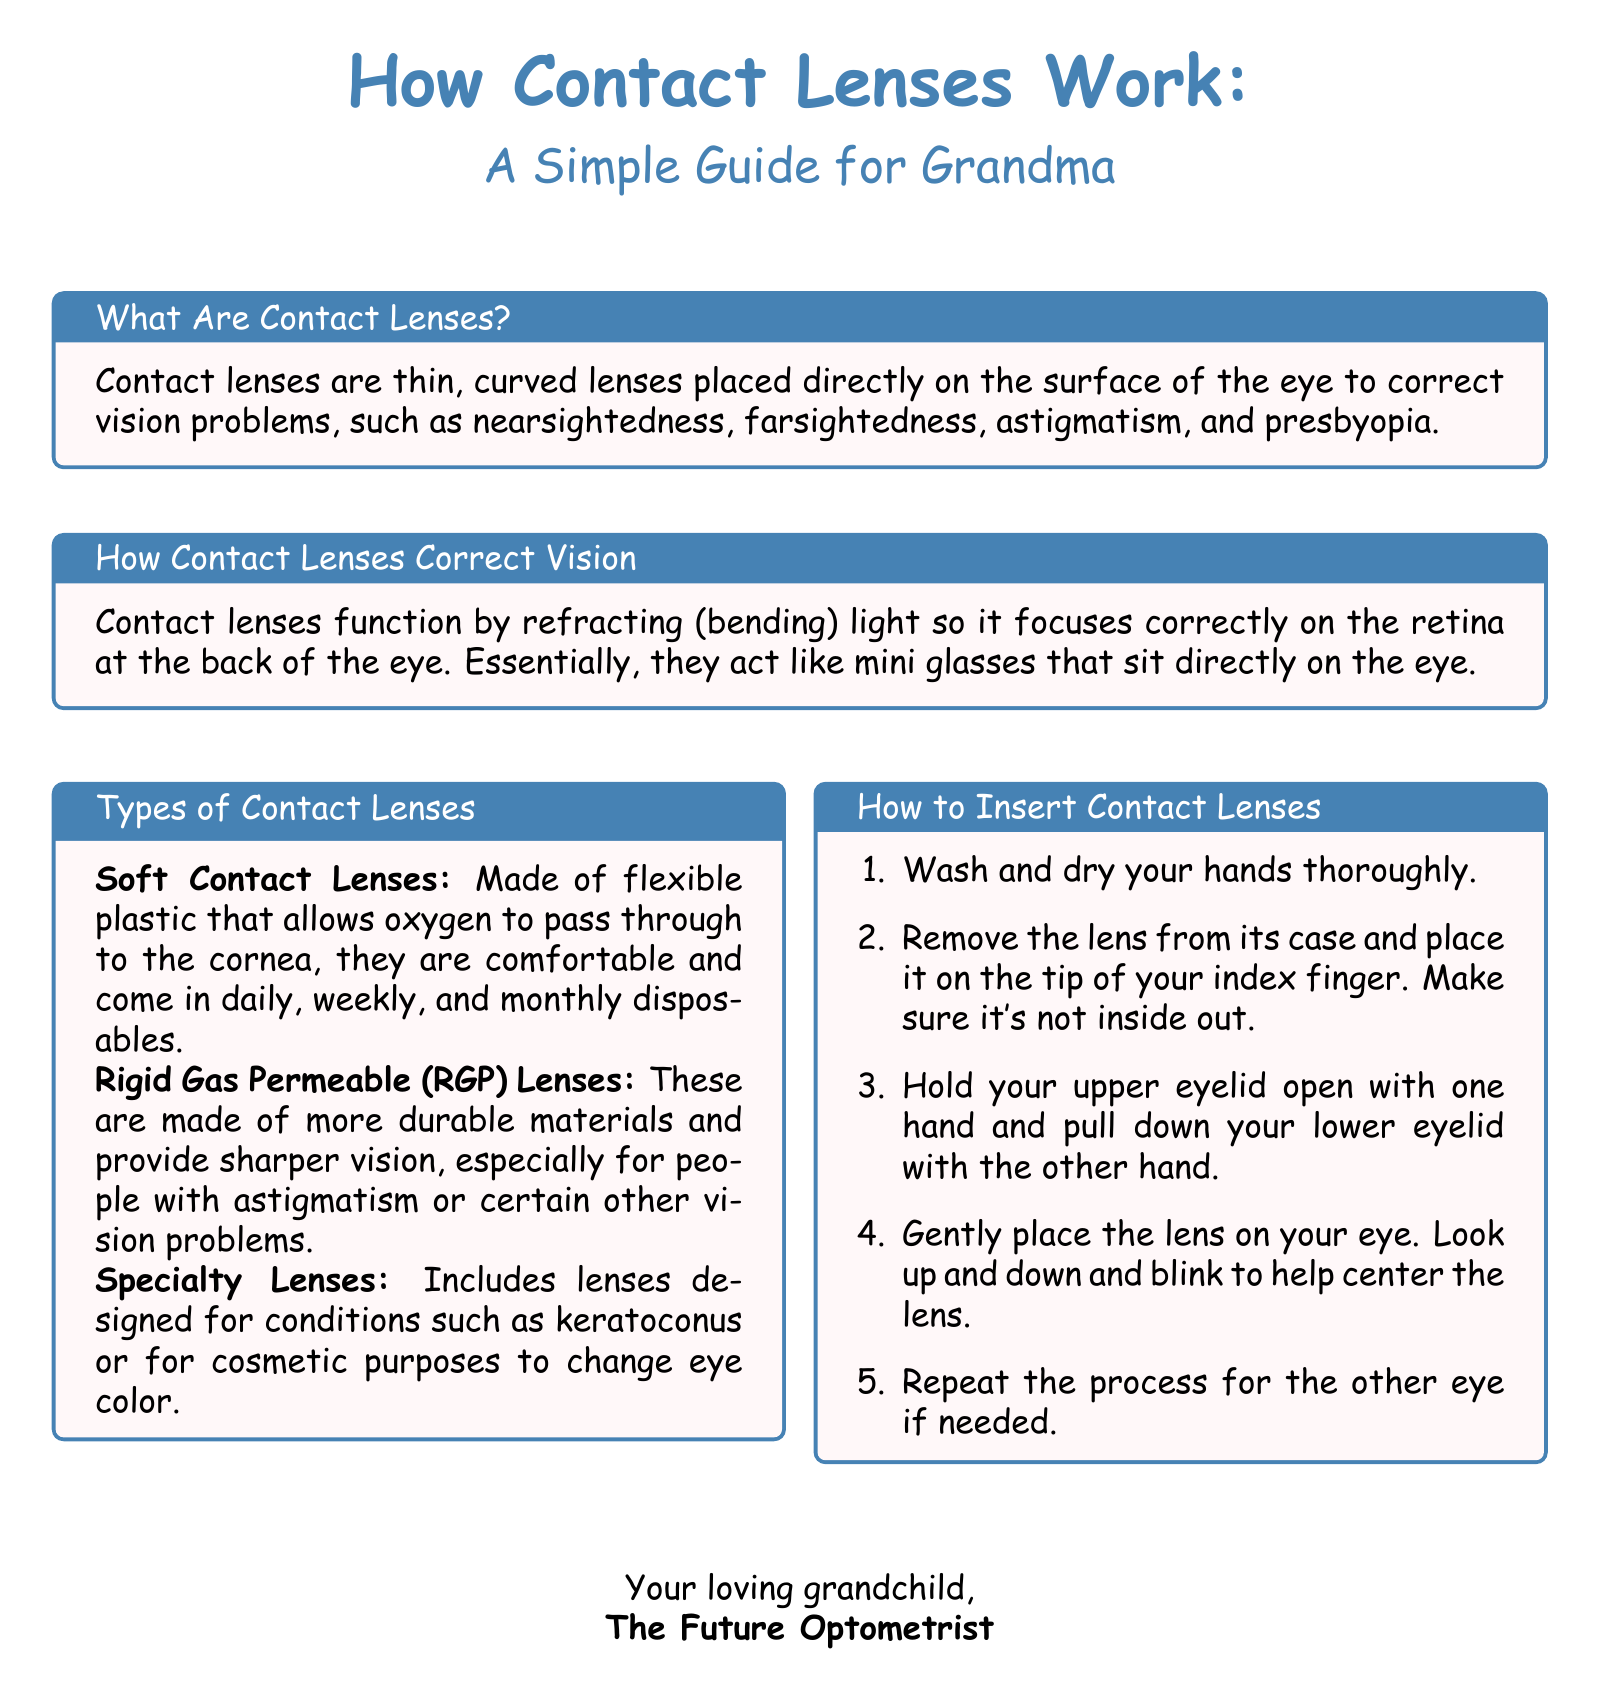What are contact lenses? The document presents a definition of contact lenses as thin, curved lenses placed directly on the surface of the eye to correct vision problems.
Answer: Thin, curved lenses How do contact lenses correct vision? The document explains that contact lenses correct vision by refracting light so it focuses correctly on the retina at the back of the eye.
Answer: Refracting light Name one type of contact lens mentioned. The document lists different types of contact lenses, including soft contact lenses, Rigid Gas Permeable (RGP) lenses, and specialty lenses.
Answer: Soft contact lenses How many steps are outlined for inserting contact lenses? The document provides a clear list of steps for inserting contact lenses. By counting those steps, we can find the answer.
Answer: Five What do soft contact lenses allow to pass through? The explanation in the document states that soft contact lenses are made of flexible plastic that allows oxygen to pass through to the cornea.
Answer: Oxygen What must you do before handling contact lenses? The document mentions the importance of washing and drying hands thoroughly before inserting contact lenses.
Answer: Wash hands What is the tone used in the greeting card? The card is designed to be simple and friendly, reflecting a caring communication style between family members.
Answer: Simple and friendly Who is the sender of the card? The document indicates that the card is signed by the future optometrist, referring to the grandchild.
Answer: The Future Optometrist 